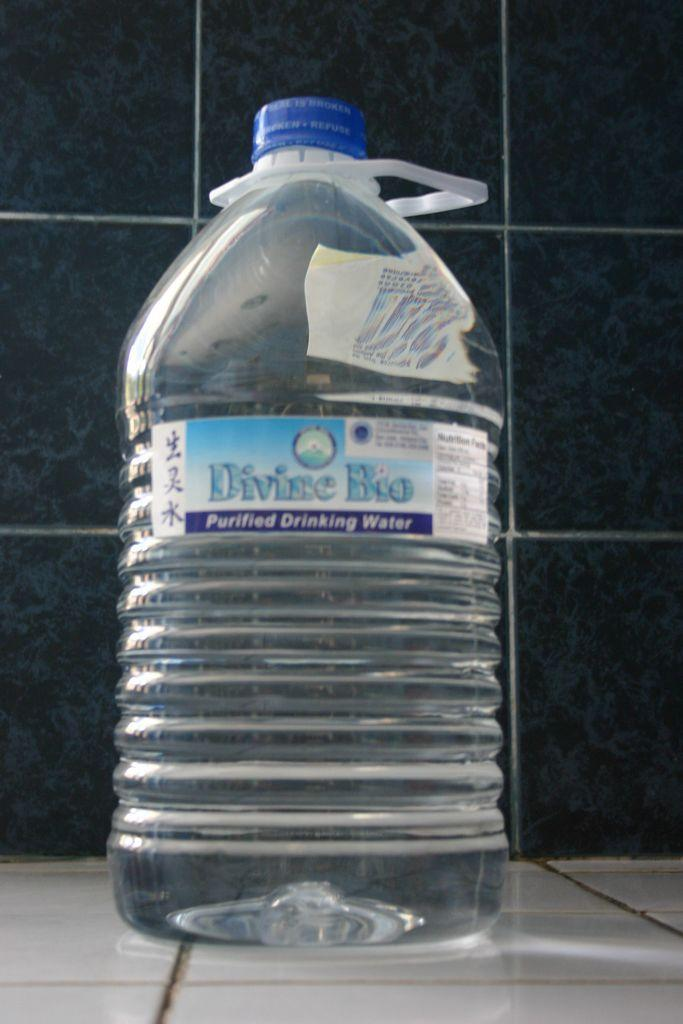<image>
Write a terse but informative summary of the picture. A big bottle of Divine Bio purified drinking water 